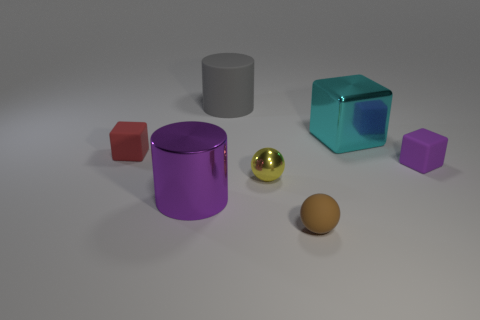Subtract all blue blocks. Subtract all brown cylinders. How many blocks are left? 3 Add 2 big cubes. How many objects exist? 9 Subtract all cylinders. How many objects are left? 5 Subtract 1 red cubes. How many objects are left? 6 Subtract all cylinders. Subtract all tiny matte blocks. How many objects are left? 3 Add 1 shiny blocks. How many shiny blocks are left? 2 Add 5 cylinders. How many cylinders exist? 7 